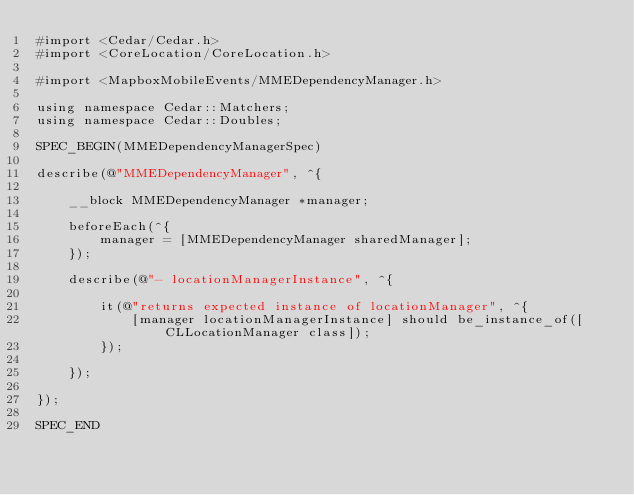Convert code to text. <code><loc_0><loc_0><loc_500><loc_500><_ObjectiveC_>#import <Cedar/Cedar.h>
#import <CoreLocation/CoreLocation.h>

#import <MapboxMobileEvents/MMEDependencyManager.h>

using namespace Cedar::Matchers;
using namespace Cedar::Doubles;

SPEC_BEGIN(MMEDependencyManagerSpec)

describe(@"MMEDependencyManager", ^{
    
    __block MMEDependencyManager *manager;
    
    beforeEach(^{
        manager = [MMEDependencyManager sharedManager];
    });
    
    describe(@"- locationManagerInstance", ^{
        
        it(@"returns expected instance of locationManager", ^{
            [manager locationManagerInstance] should be_instance_of([CLLocationManager class]);
        });
        
    });
    
});

SPEC_END
</code> 